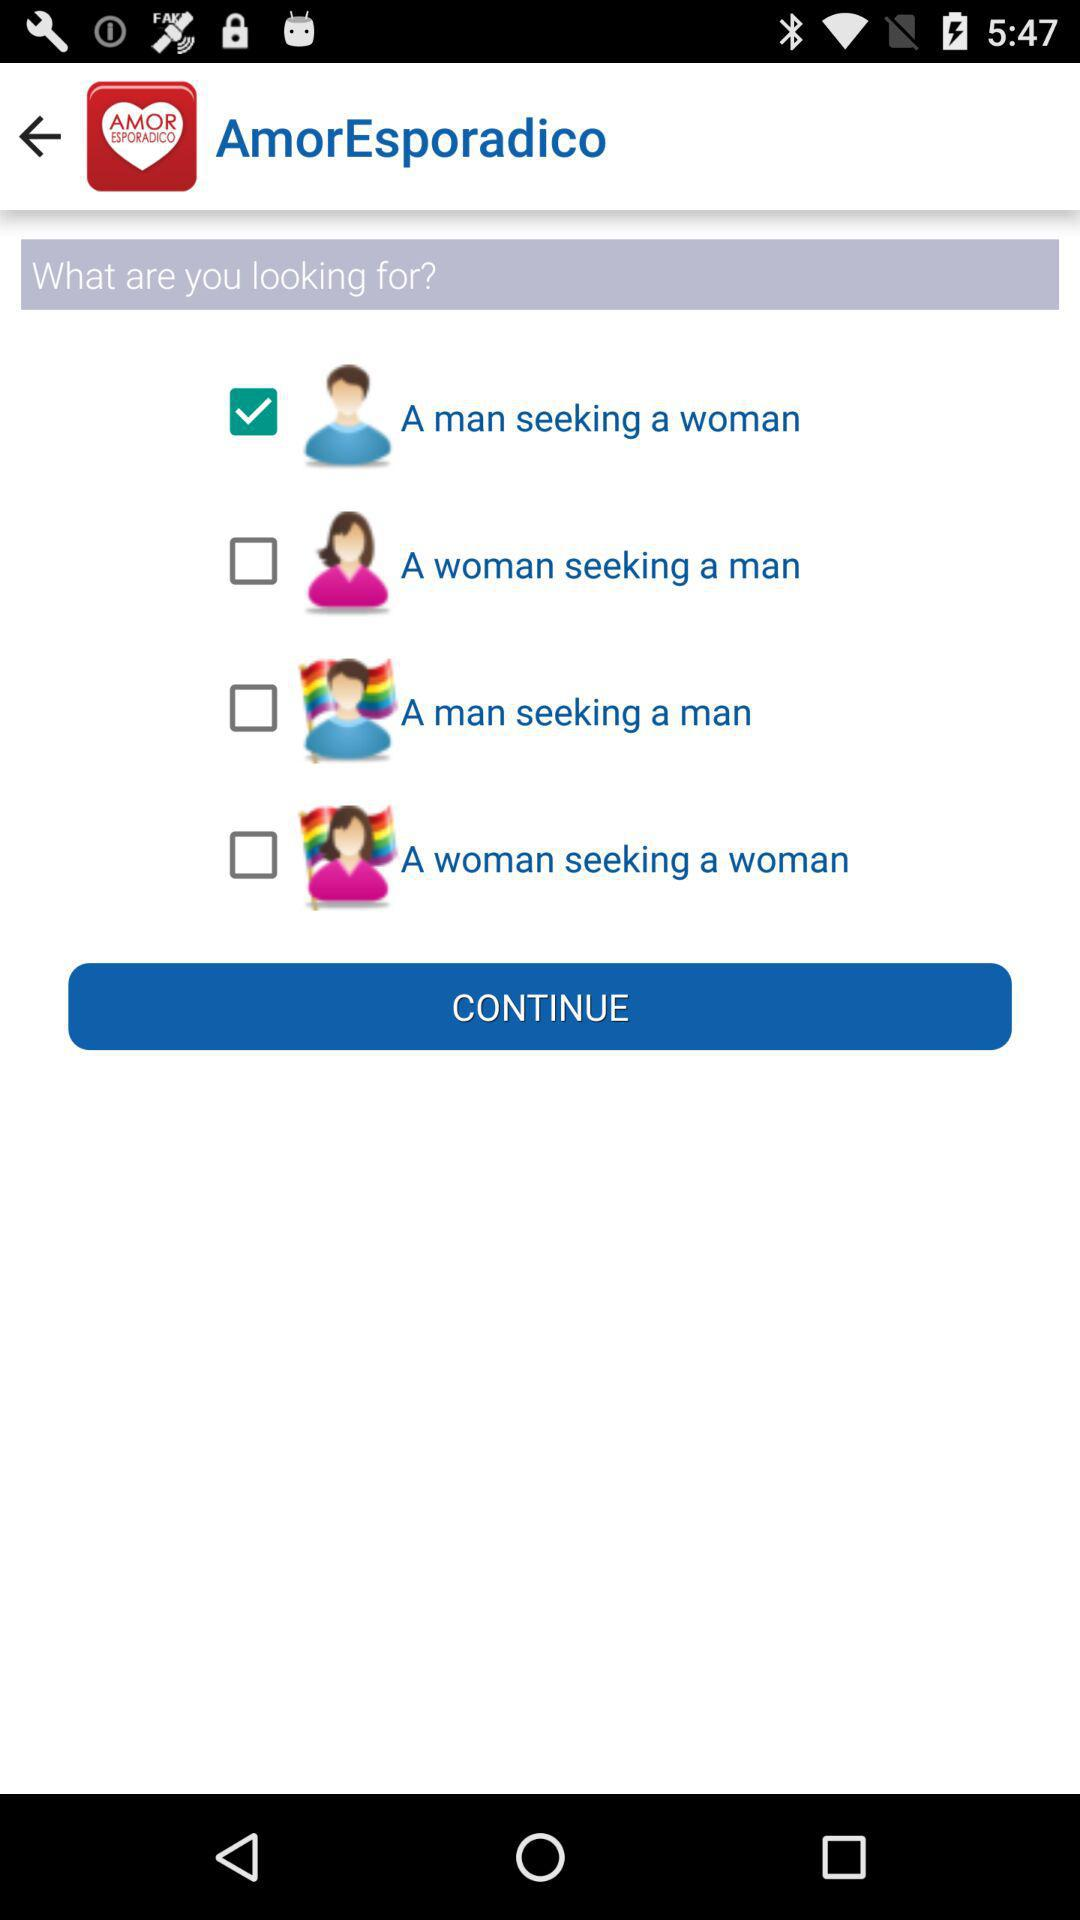What is the name of the application? The name of the application is "AmorEsporadico". 